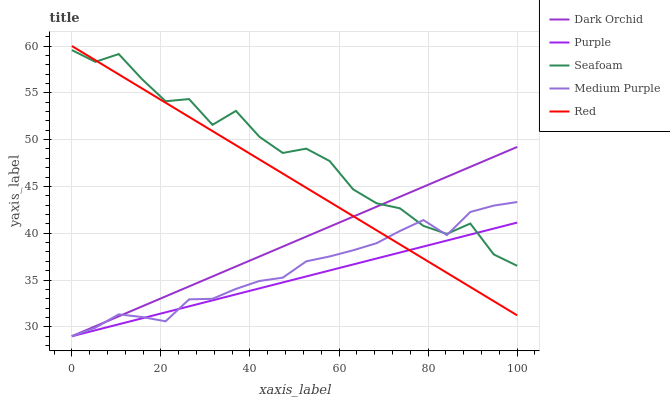Does Purple have the minimum area under the curve?
Answer yes or no. Yes. Does Seafoam have the maximum area under the curve?
Answer yes or no. Yes. Does Medium Purple have the minimum area under the curve?
Answer yes or no. No. Does Medium Purple have the maximum area under the curve?
Answer yes or no. No. Is Purple the smoothest?
Answer yes or no. Yes. Is Seafoam the roughest?
Answer yes or no. Yes. Is Medium Purple the smoothest?
Answer yes or no. No. Is Medium Purple the roughest?
Answer yes or no. No. Does Purple have the lowest value?
Answer yes or no. Yes. Does Red have the lowest value?
Answer yes or no. No. Does Red have the highest value?
Answer yes or no. Yes. Does Medium Purple have the highest value?
Answer yes or no. No. Does Red intersect Dark Orchid?
Answer yes or no. Yes. Is Red less than Dark Orchid?
Answer yes or no. No. Is Red greater than Dark Orchid?
Answer yes or no. No. 